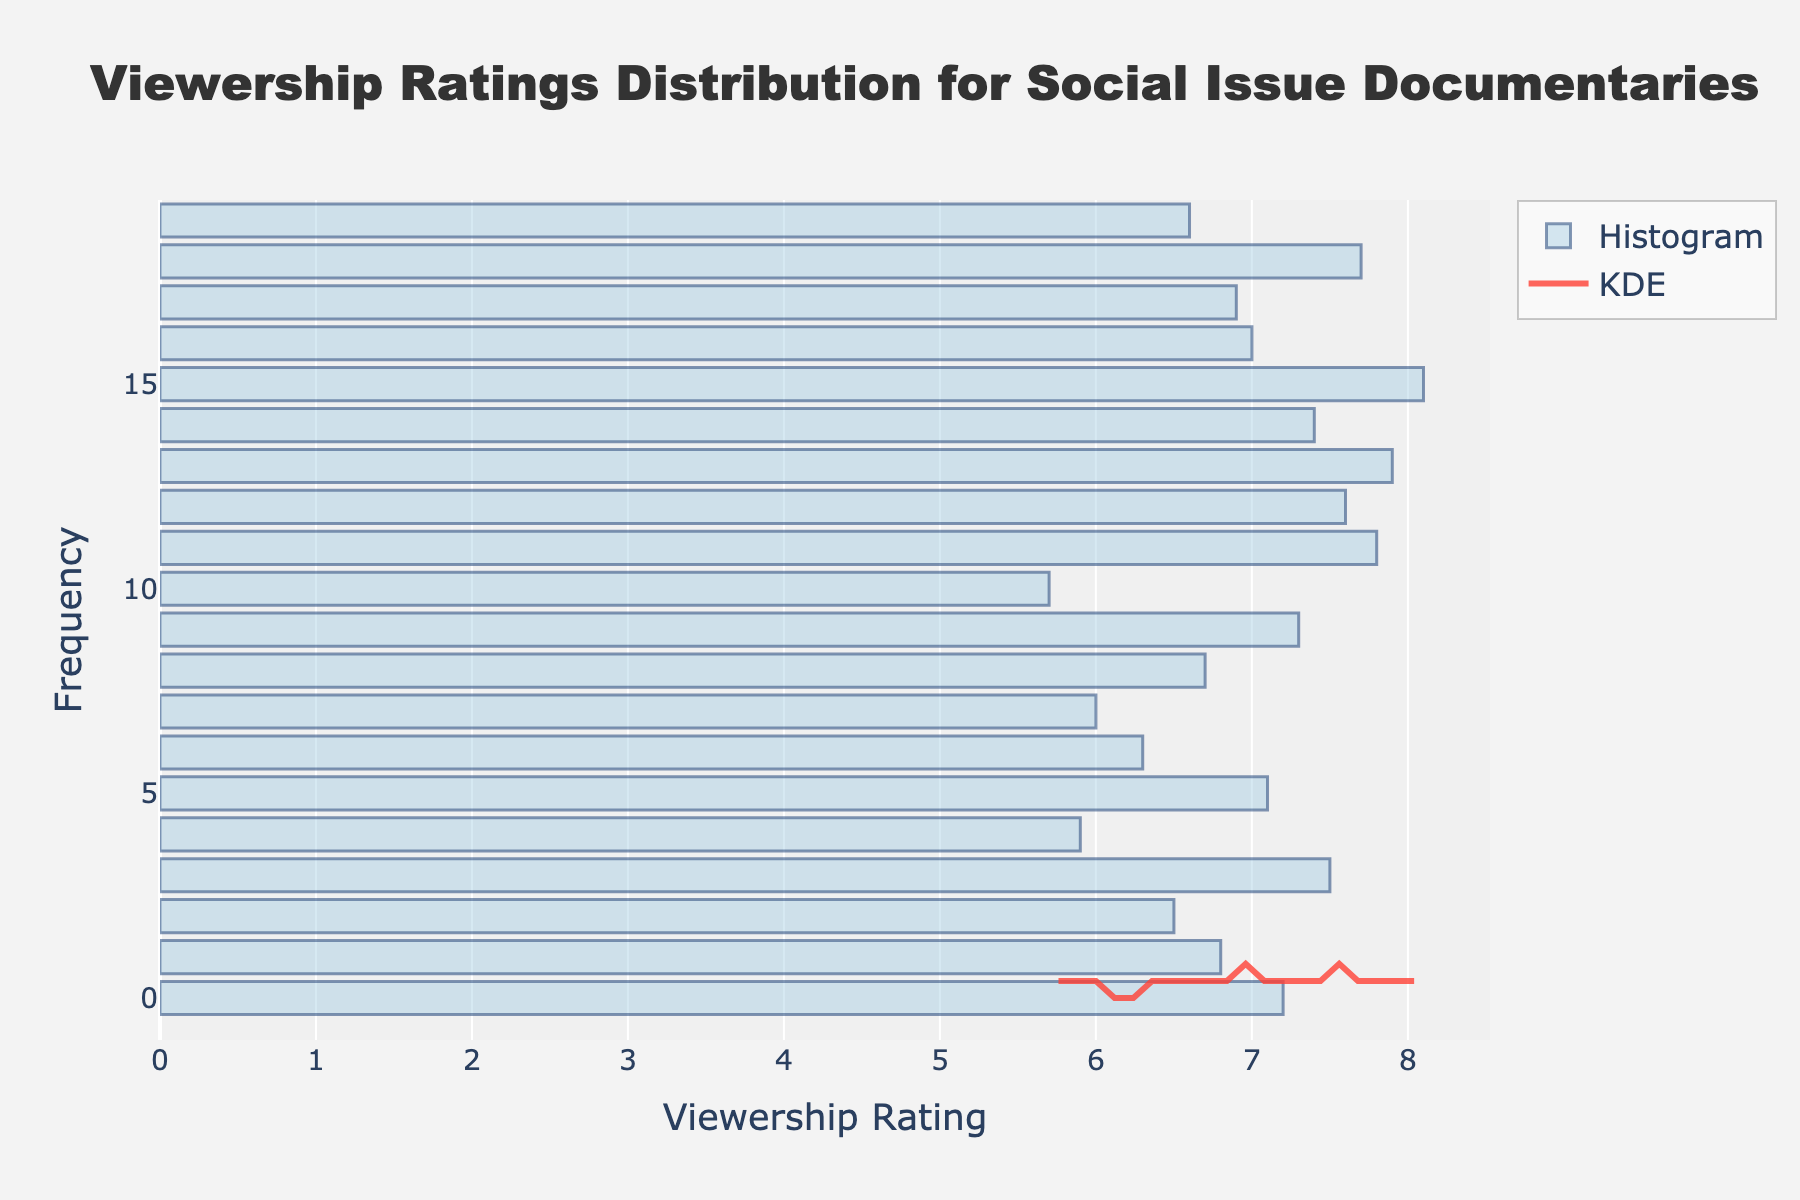What is the title of the figure? The title of the figure is written prominently at the top and usually provides the main subject or message of the chart. In this figure, the title is "Viewership Ratings Distribution for Social Issue Documentaries."
Answer: Viewership Ratings Distribution for Social Issue Documentaries What is the range of viewership ratings shown on the x-axis? The x-axis represents the viewership ratings. By looking at the figure's x-axis, you can see that the ratings range from around 5.5 to 8.5.
Answer: 5.5 to 8.5 Which streaming platform has the highest viewership rating? By observing individual data points or bars on the histogram, the highest viewership rating is associated with the Criterion Channel, which is 8.1.
Answer: Criterion Channel How does the KDE (density curve) reflect the frequency of the viewership ratings? The KDE line shows the distribution of data points across the range of viewership ratings. Where the KDE curve is higher, there are more frequent ratings; where it is lower, ratings are less frequent. The KDE helps smooth out the histogram bars and gives a visual representation of the density of ratings within the range.
Answer: It shows the density of ratings What is the most common range of viewership ratings based on the KDE? The most common range of viewership ratings is where the KDE curve peaks the highest. This peak appears to be around 7.0 to 7.5.
Answer: 7.0 to 7.5 How many streaming platforms have viewership ratings above 7.0? By counting the individual bars or data points above the 7.0 mark on the x-axis, you find that 10 platforms have ratings above 7.0.
Answer: 10 What is the difference between the highest and lowest viewership ratings? The highest rating is 8.1 (Criterion Channel) and the lowest rating is 5.7 (Tubi). The difference is calculated as 8.1 - 5.7.
Answer: 2.4 Which platform falls in the mid-point range of the most common ratings? The most common range is around 7.0 to 7.5. By viewing the data points closely, platforms like Netflix (7.2), Hulu (6.8), and Amazon Prime (6.5) fall near this range, but Netflix at 7.2 is within this mid-point range and fits best.
Answer: Netflix Do more platforms have ratings above or below the mean viewership rating? First, calculate the mean (average) viewership rating. Sum up all the ratings and divide by the number of platforms (20). After calculating, you'll compare the number of ratings above and below this mean.
Answer: More above Which platform corresponds to the peak of the KDE curve? The KDE curve peaks around the ratings 7.0 to 7.5. Platforms like Netflix, HBO Max, and PBS, which fall in this range, contribute to this peak. Netflix (7.2) is a prominent platform contributing to this peak.
Answer: Netflix 